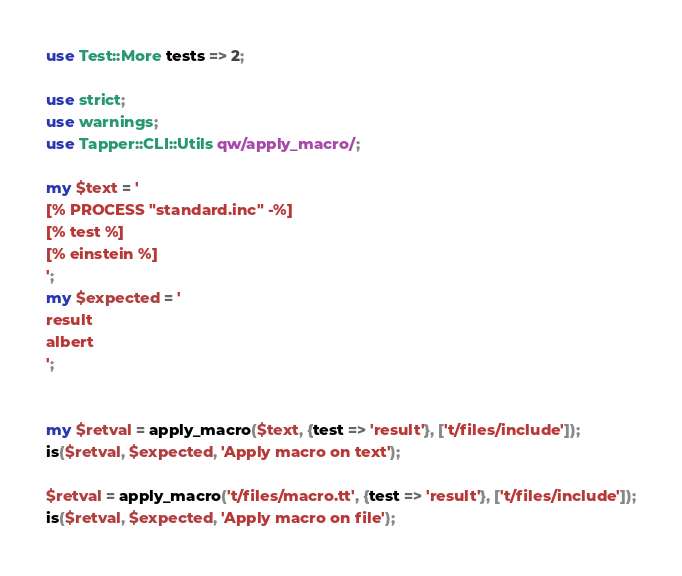<code> <loc_0><loc_0><loc_500><loc_500><_Perl_>use Test::More tests => 2;

use strict;
use warnings;
use Tapper::CLI::Utils qw/apply_macro/;

my $text = '
[% PROCESS "standard.inc" -%]
[% test %]
[% einstein %]
';
my $expected = '
result
albert
';


my $retval = apply_macro($text, {test => 'result'}, ['t/files/include']);
is($retval, $expected, 'Apply macro on text');

$retval = apply_macro('t/files/macro.tt', {test => 'result'}, ['t/files/include']);
is($retval, $expected, 'Apply macro on file');
</code> 